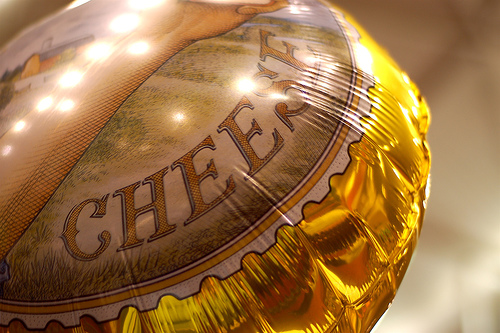<image>
Is there a cheese next to the balloon? No. The cheese is not positioned next to the balloon. They are located in different areas of the scene. 